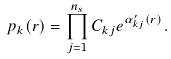<formula> <loc_0><loc_0><loc_500><loc_500>p _ { k } ( r ) = \prod _ { j = 1 } ^ { n _ { s } } C _ { k j } e ^ { \alpha ^ { \prime } _ { k j } ( r ) } .</formula> 